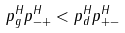<formula> <loc_0><loc_0><loc_500><loc_500>p ^ { H } _ { g } p ^ { H } _ { - + } < p ^ { H } _ { d } p ^ { H } _ { + - }</formula> 